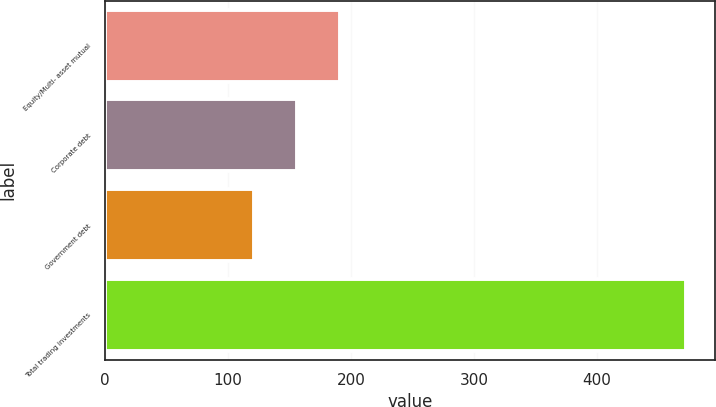Convert chart. <chart><loc_0><loc_0><loc_500><loc_500><bar_chart><fcel>Equity/Multi- asset mutual<fcel>Corporate debt<fcel>Government debt<fcel>Total trading investments<nl><fcel>191.2<fcel>156.1<fcel>121<fcel>472<nl></chart> 